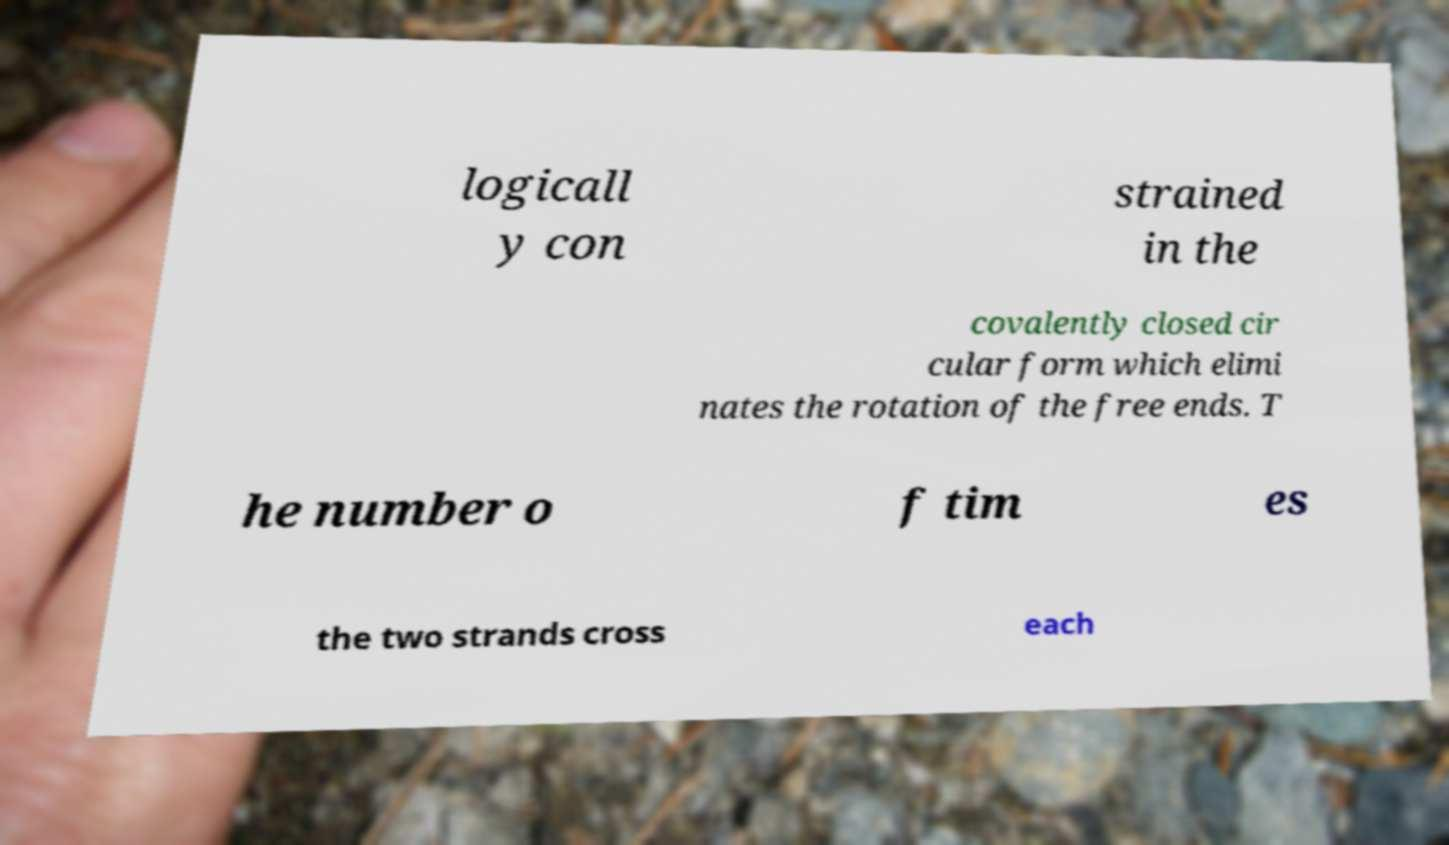Could you assist in decoding the text presented in this image and type it out clearly? logicall y con strained in the covalently closed cir cular form which elimi nates the rotation of the free ends. T he number o f tim es the two strands cross each 